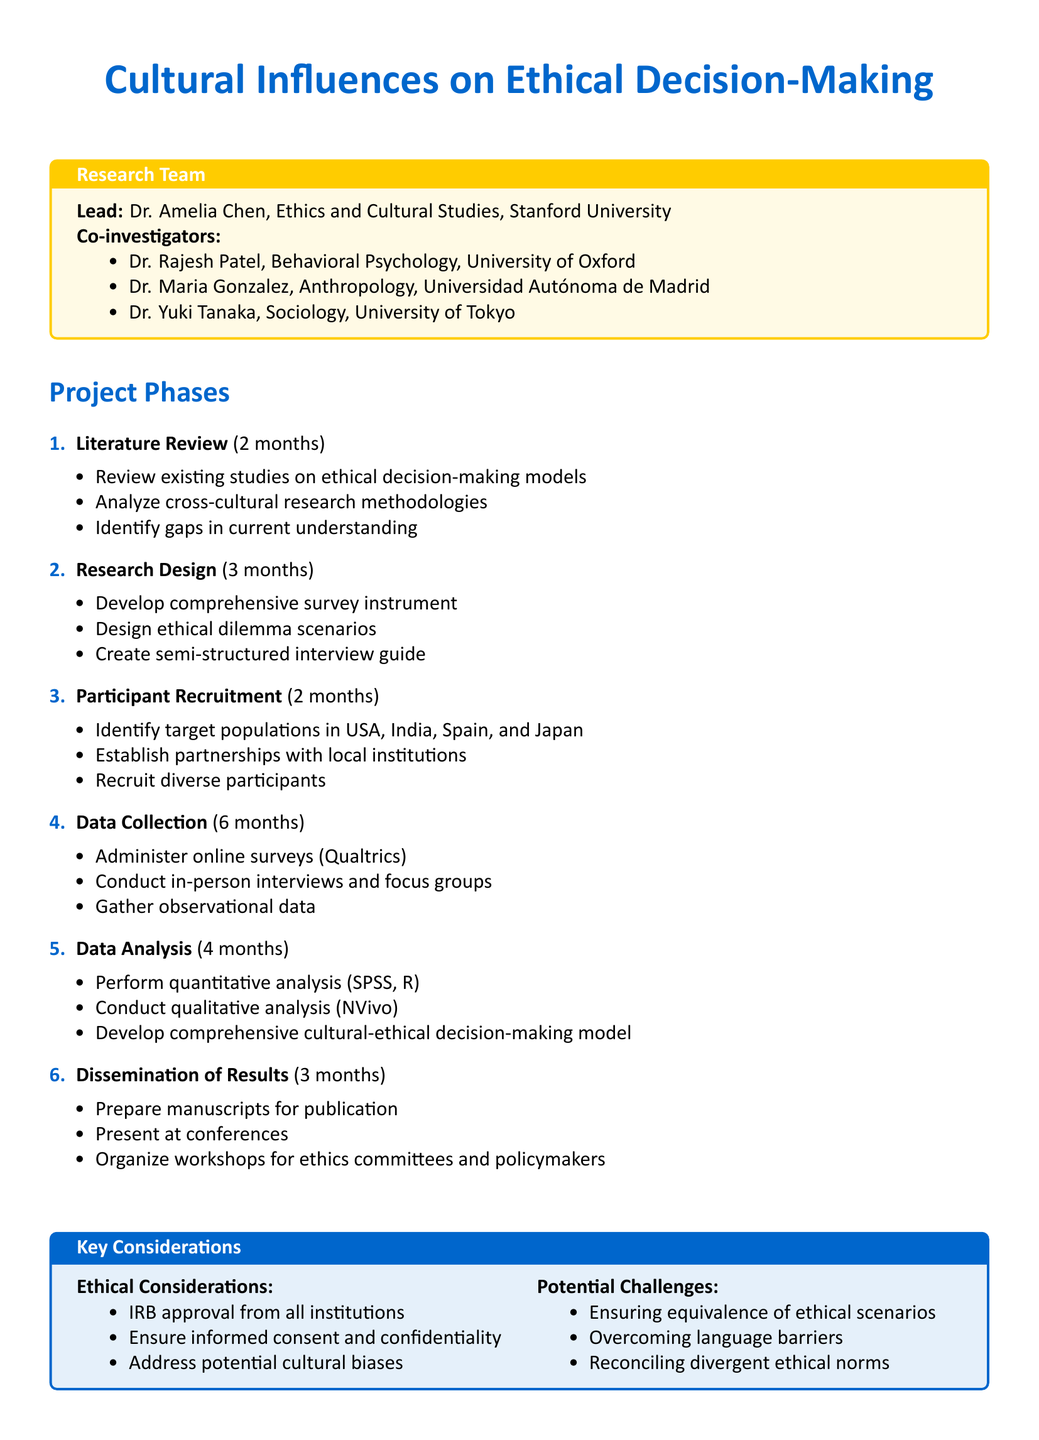What is the project title? The project title is stated at the beginning of the document.
Answer: Cultural Influences on Ethical Decision-Making: A Cross-Cultural Study Who is the lead investigator? The lead investigator's name and affiliation are mentioned in the research team section.
Answer: Dr. Amelia Chen, Ethics and Cultural Studies, Stanford University How long is the data collection phase? The duration of each phase is listed, specifically for data collection.
Answer: 6 months What are the names of the co-investigators? The document lists the co-investigators in the research team section.
Answer: Dr. Rajesh Patel, Dr. Maria Gonzalez, Dr. Yuki Tanaka Which tool is used for virtual meetings? Collaboration tools are specified in the document, detailing their specific uses.
Answer: Zoom What is one of the expected outcomes? The expected outcomes section outlines results anticipated from the project.
Answer: Development of a culturally-sensitive ethical decision-making framework What is a potential challenge mentioned in the document? The document provides a list of potential challenges that the study may face.
Answer: Ensuring equivalence of ethical scenarios across cultures How many months are allocated for the research design phase? The duration for the research design phase is stated in the project outline.
Answer: 3 months 